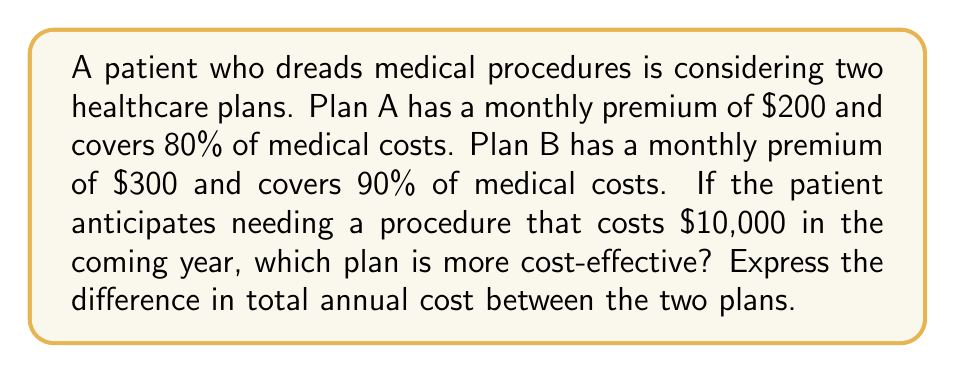Show me your answer to this math problem. Let's approach this step-by-step:

1) First, calculate the annual premium for each plan:
   Plan A: $200 × 12 = $2,400
   Plan B: $300 × 12 = $3,600

2) Now, calculate the patient's out-of-pocket cost for the procedure under each plan:
   Plan A: $10,000 × (1 - 0.80) = $2,000
   Plan B: $10,000 × (1 - 0.90) = $1,000

3) Calculate the total annual cost for each plan:
   Plan A: $2,400 + $2,000 = $4,400
   Plan B: $3,600 + $1,000 = $4,600

4) Calculate the difference in total annual cost:
   Difference = Cost of Plan B - Cost of Plan A
               = $4,600 - $4,400 = $200

5) Express this as a mathematical equation:

   $$\Delta C = (P_B \times 12 + M \times (1-C_B)) - (P_A \times 12 + M \times (1-C_A))$$

   Where:
   $\Delta C$ = Difference in total annual cost
   $P_B$ = Monthly premium for Plan B
   $P_A$ = Monthly premium for Plan A
   $M$ = Cost of medical procedure
   $C_B$ = Coverage percentage for Plan B
   $C_A$ = Coverage percentage for Plan A

6) Plugging in the values:

   $$\Delta C = (300 \times 12 + 10000 \times (1-0.90)) - (200 \times 12 + 10000 \times (1-0.80)) = 200$$

Therefore, Plan A is more cost-effective by $200 annually.
Answer: $200 